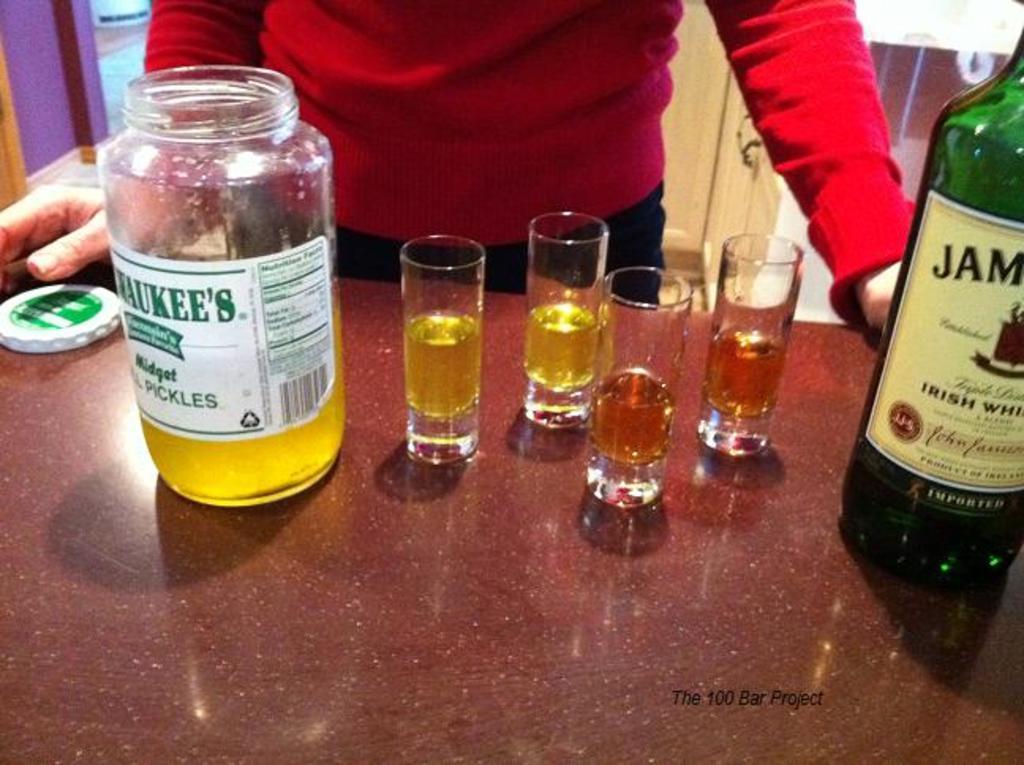What kind of whisky is in the bottle?
Keep it short and to the point. Irish. What is in the jar on the left?
Keep it short and to the point. Pickles. 